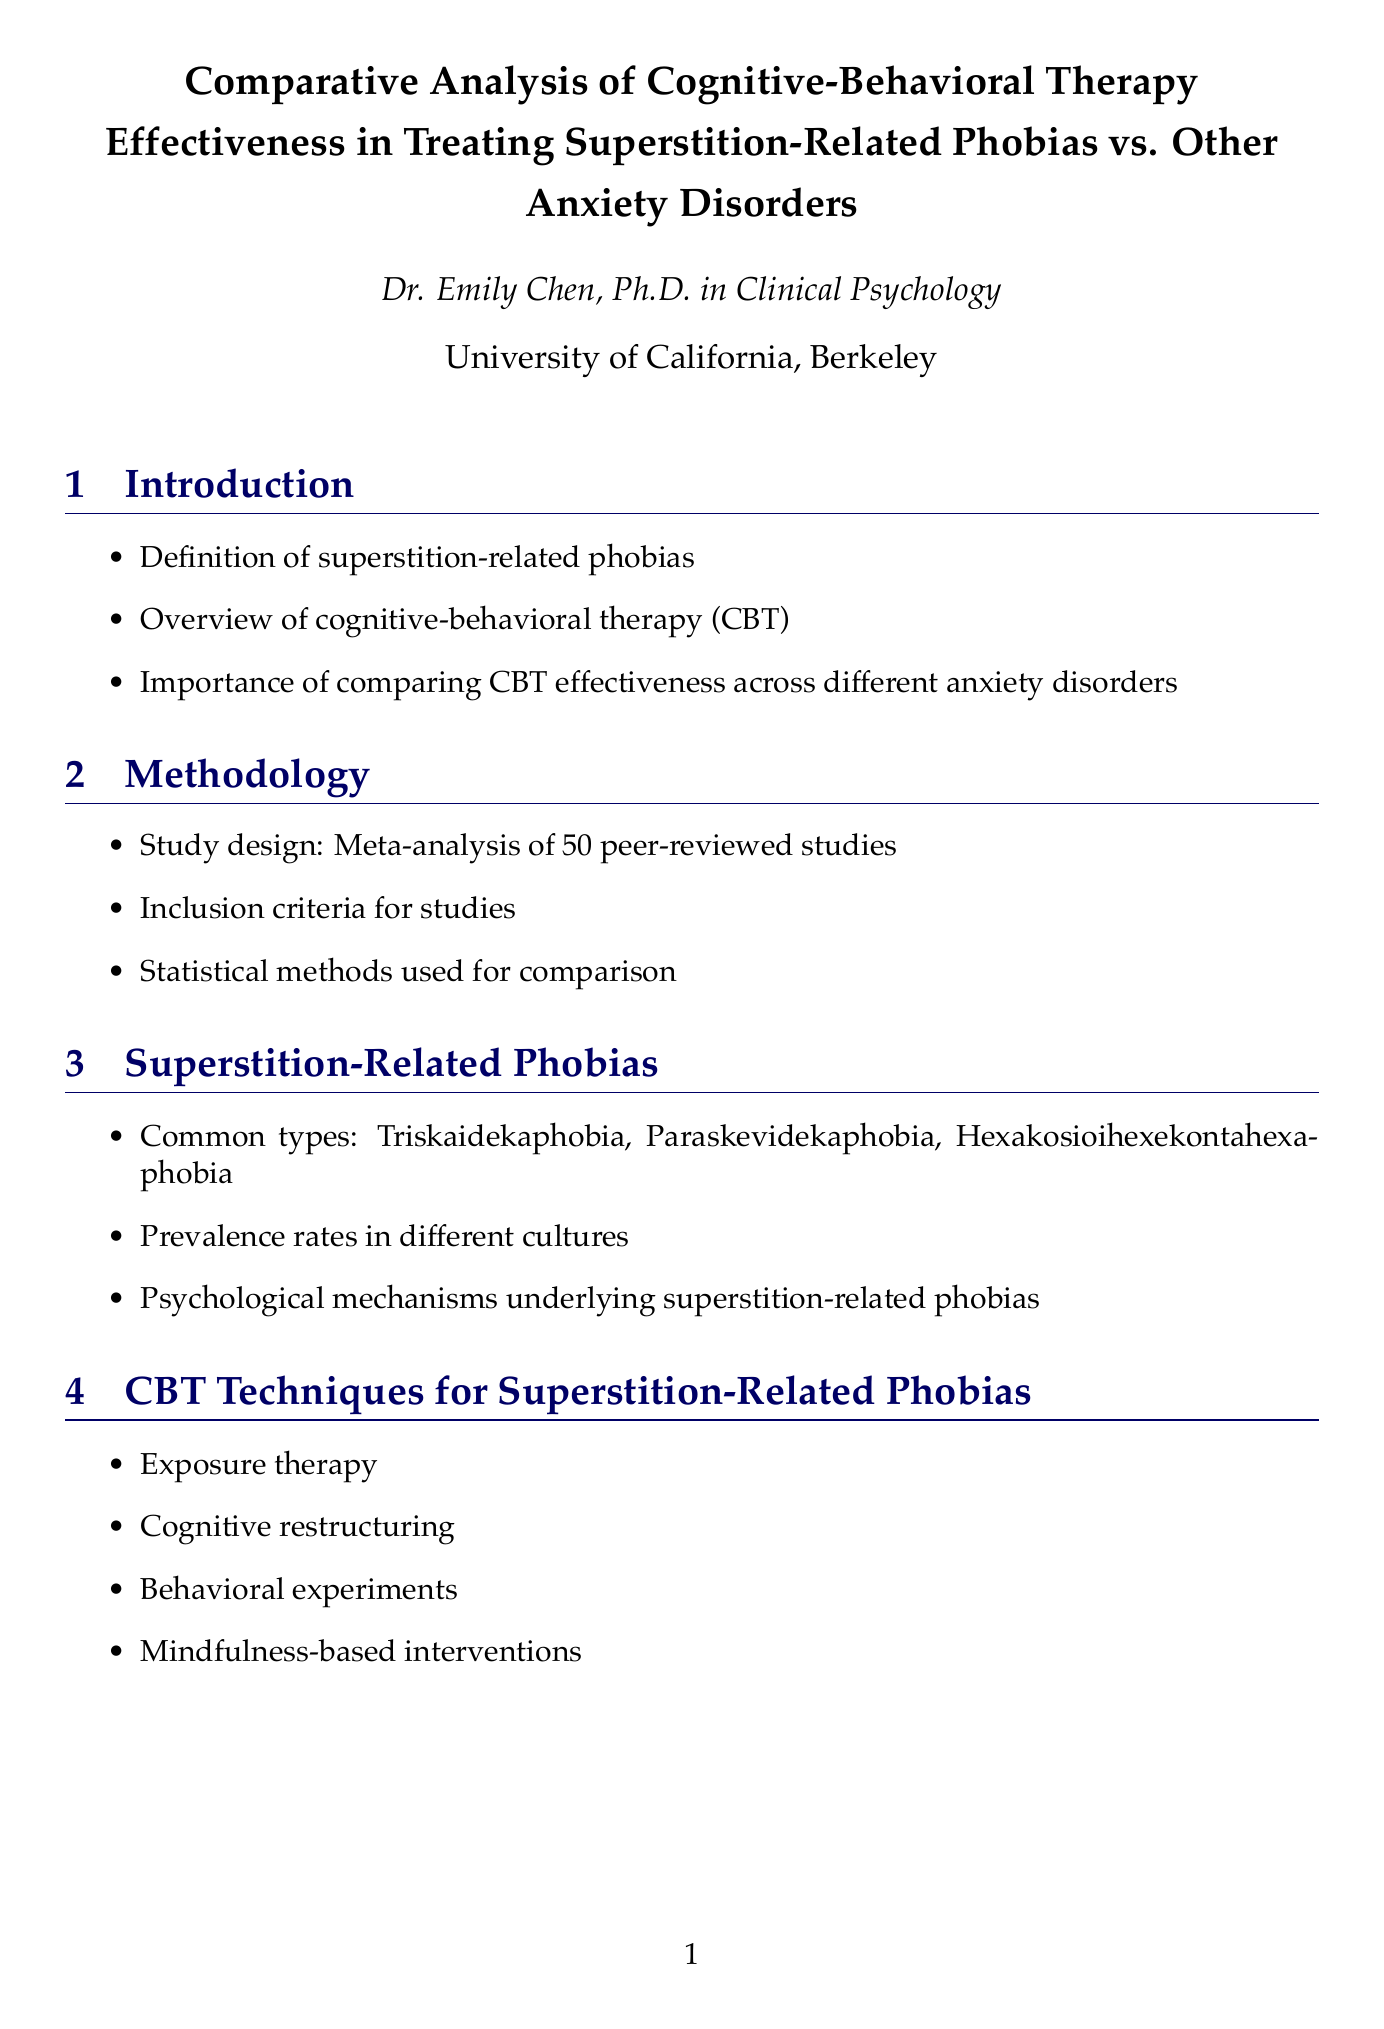What is the title of the report? The title of the report is explicitly mentioned at the beginning of the document.
Answer: Comparative Analysis of Cognitive-Behavioral Therapy Effectiveness in Treating Superstition-Related Phobias vs. Other Anxiety Disorders Who is the author of the report? The author of the report is specified in the author section.
Answer: Dr. Emily Chen, Ph.D. in Clinical Psychology What is the sample size of the studies included in the meta-analysis? The methodology section states the sample size for the studies that were involved in the meta-analysis.
Answer: 50 peer-reviewed studies What is the effect size for CBT in superstition-related phobias? The results section contains specific effect sizes for CBT treatments in superstition-related phobias.
Answer: 0.82 Which cultural group has the highest prevalence of superstition-related phobias? The pie chart data in the document provides the prevalence rates by culture, showing which group has the highest percentage.
Answer: East Asian What are the techniques used in CBT for superstition-related phobias? The content under CBT techniques lists the various methods applied for addressing superstition-related phobias.
Answer: Exposure therapy, Cognitive restructuring, Behavioral experiments, Mindfulness-based interventions What is one implication for clinical practice discussed in the report? The discussion section highlights implications that can be drawn from the findings presented in the results.
Answer: Tailoring CBT approaches for superstition-related phobias What type of chart is used to demonstrate effect sizes of CBT across anxiety disorders? Data visualization in the document specifies the types of visual representation used for displaying important data, including charts.
Answer: Bar Chart 